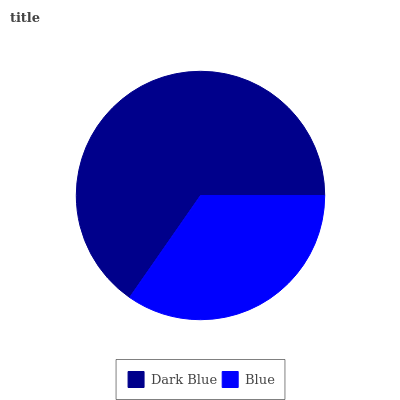Is Blue the minimum?
Answer yes or no. Yes. Is Dark Blue the maximum?
Answer yes or no. Yes. Is Blue the maximum?
Answer yes or no. No. Is Dark Blue greater than Blue?
Answer yes or no. Yes. Is Blue less than Dark Blue?
Answer yes or no. Yes. Is Blue greater than Dark Blue?
Answer yes or no. No. Is Dark Blue less than Blue?
Answer yes or no. No. Is Dark Blue the high median?
Answer yes or no. Yes. Is Blue the low median?
Answer yes or no. Yes. Is Blue the high median?
Answer yes or no. No. Is Dark Blue the low median?
Answer yes or no. No. 